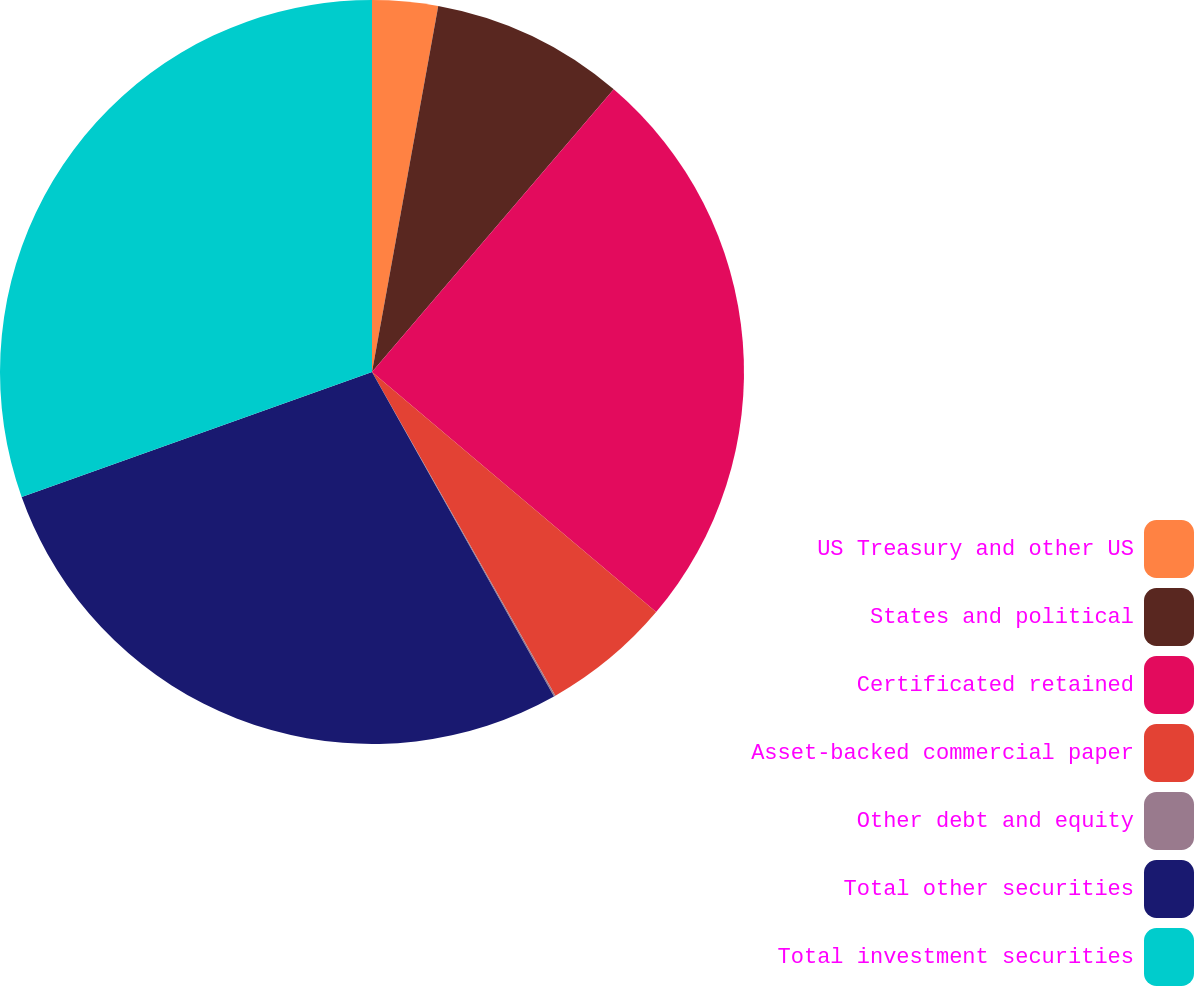<chart> <loc_0><loc_0><loc_500><loc_500><pie_chart><fcel>US Treasury and other US<fcel>States and political<fcel>Certificated retained<fcel>Asset-backed commercial paper<fcel>Other debt and equity<fcel>Total other securities<fcel>Total investment securities<nl><fcel>2.85%<fcel>8.41%<fcel>24.91%<fcel>5.63%<fcel>0.07%<fcel>27.68%<fcel>30.46%<nl></chart> 